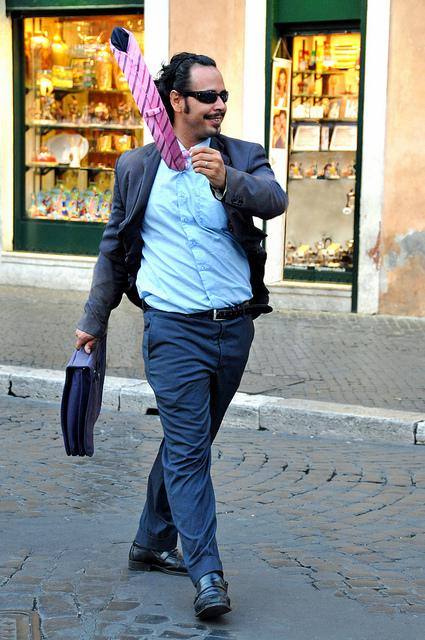What is this man experiencing? Please explain your reasoning. high wind. The man's necktie is blowing up in the wind. 